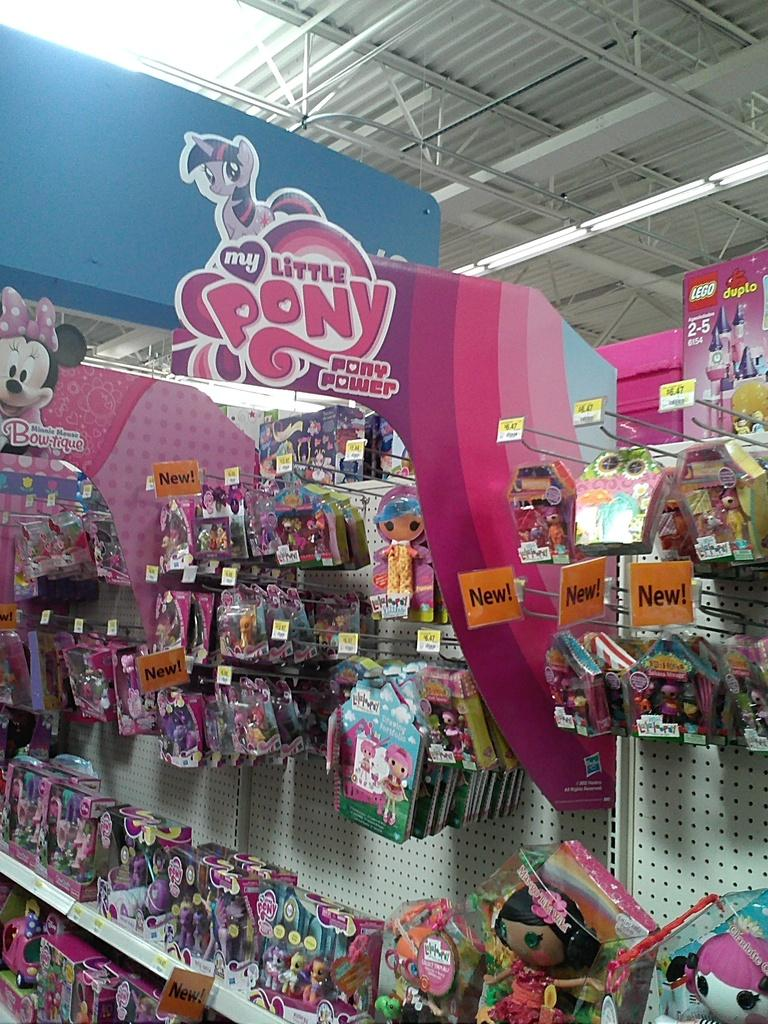<image>
Describe the image concisely. A My Little Pony sign is hanging above a store shelf. 